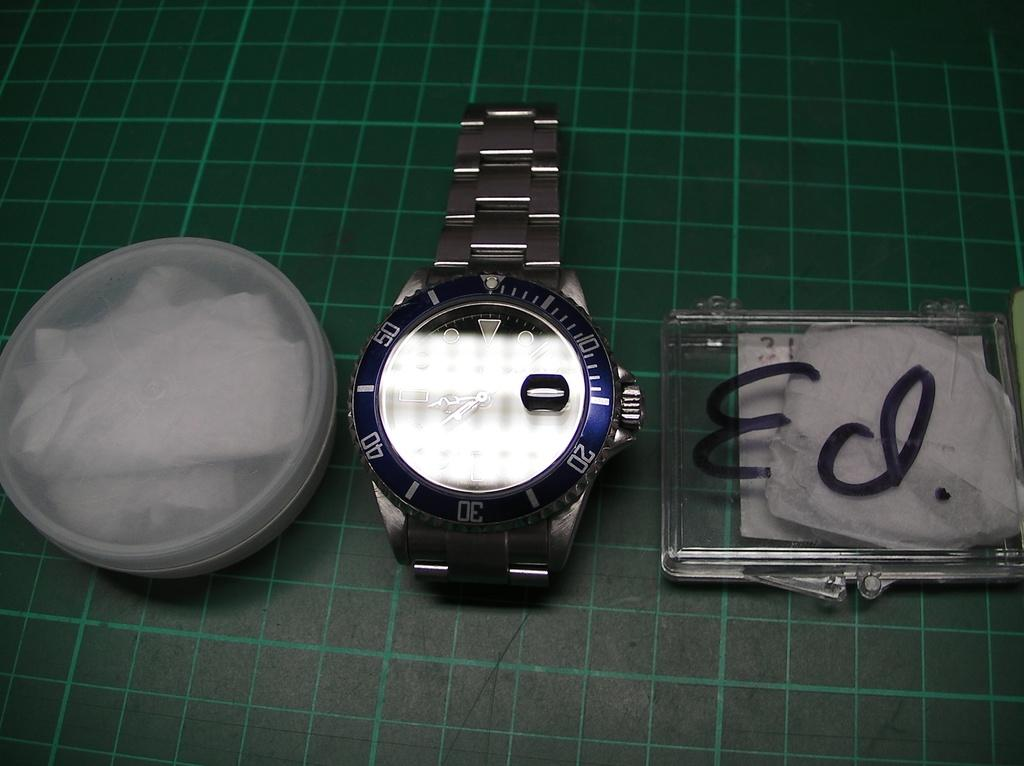What type of object is visible in the image? There is a wrist watch in the image. What other objects can be seen in the image? There is a box and a container in the image. Where are these objects located? All objects are placed on a surface. What type of harmony can be heard in the image? There is no audible sound or harmony present in the image, as it only features objects such as a wrist watch, box, and container. 